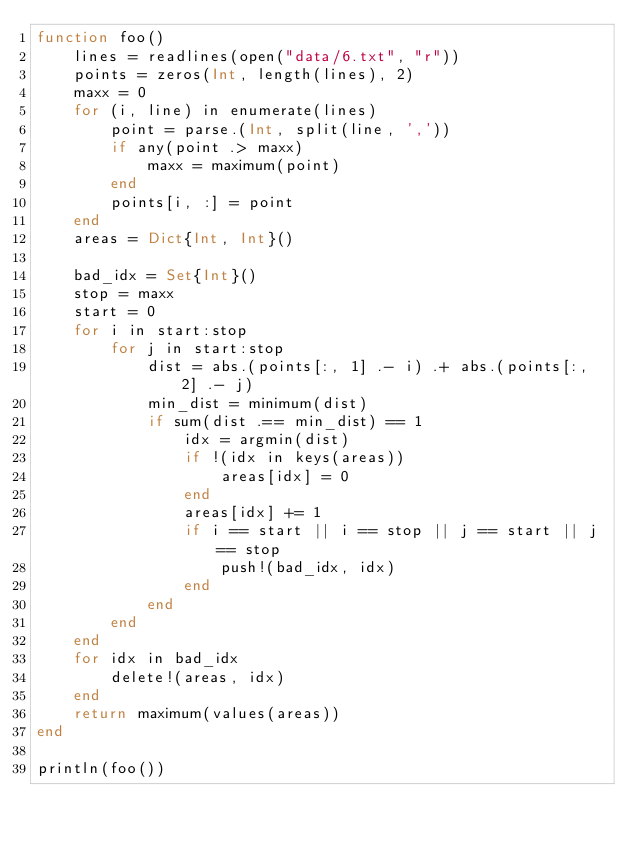<code> <loc_0><loc_0><loc_500><loc_500><_Julia_>function foo()
    lines = readlines(open("data/6.txt", "r"))
    points = zeros(Int, length(lines), 2)
    maxx = 0
    for (i, line) in enumerate(lines)
        point = parse.(Int, split(line, ','))
        if any(point .> maxx)
            maxx = maximum(point)
        end
        points[i, :] = point
    end
    areas = Dict{Int, Int}()

    bad_idx = Set{Int}()
    stop = maxx
    start = 0
    for i in start:stop
        for j in start:stop
            dist = abs.(points[:, 1] .- i) .+ abs.(points[:, 2] .- j)
            min_dist = minimum(dist)
            if sum(dist .== min_dist) == 1
                idx = argmin(dist)
                if !(idx in keys(areas))
                    areas[idx] = 0
                end
                areas[idx] += 1
                if i == start || i == stop || j == start || j == stop
                    push!(bad_idx, idx)
                end
            end
        end
    end
    for idx in bad_idx
        delete!(areas, idx)
    end
    return maximum(values(areas))
end

println(foo())
</code> 